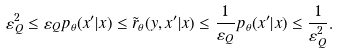<formula> <loc_0><loc_0><loc_500><loc_500>\varepsilon _ { Q } ^ { 2 } \leq \varepsilon _ { Q } p _ { \theta } ( x ^ { \prime } | x ) \leq \tilde { r } _ { \theta } ( y , x ^ { \prime } | x ) \leq \frac { 1 } { \varepsilon _ { Q } } p _ { \theta } ( x ^ { \prime } | x ) \leq \frac { 1 } { \varepsilon _ { Q } ^ { 2 } } .</formula> 